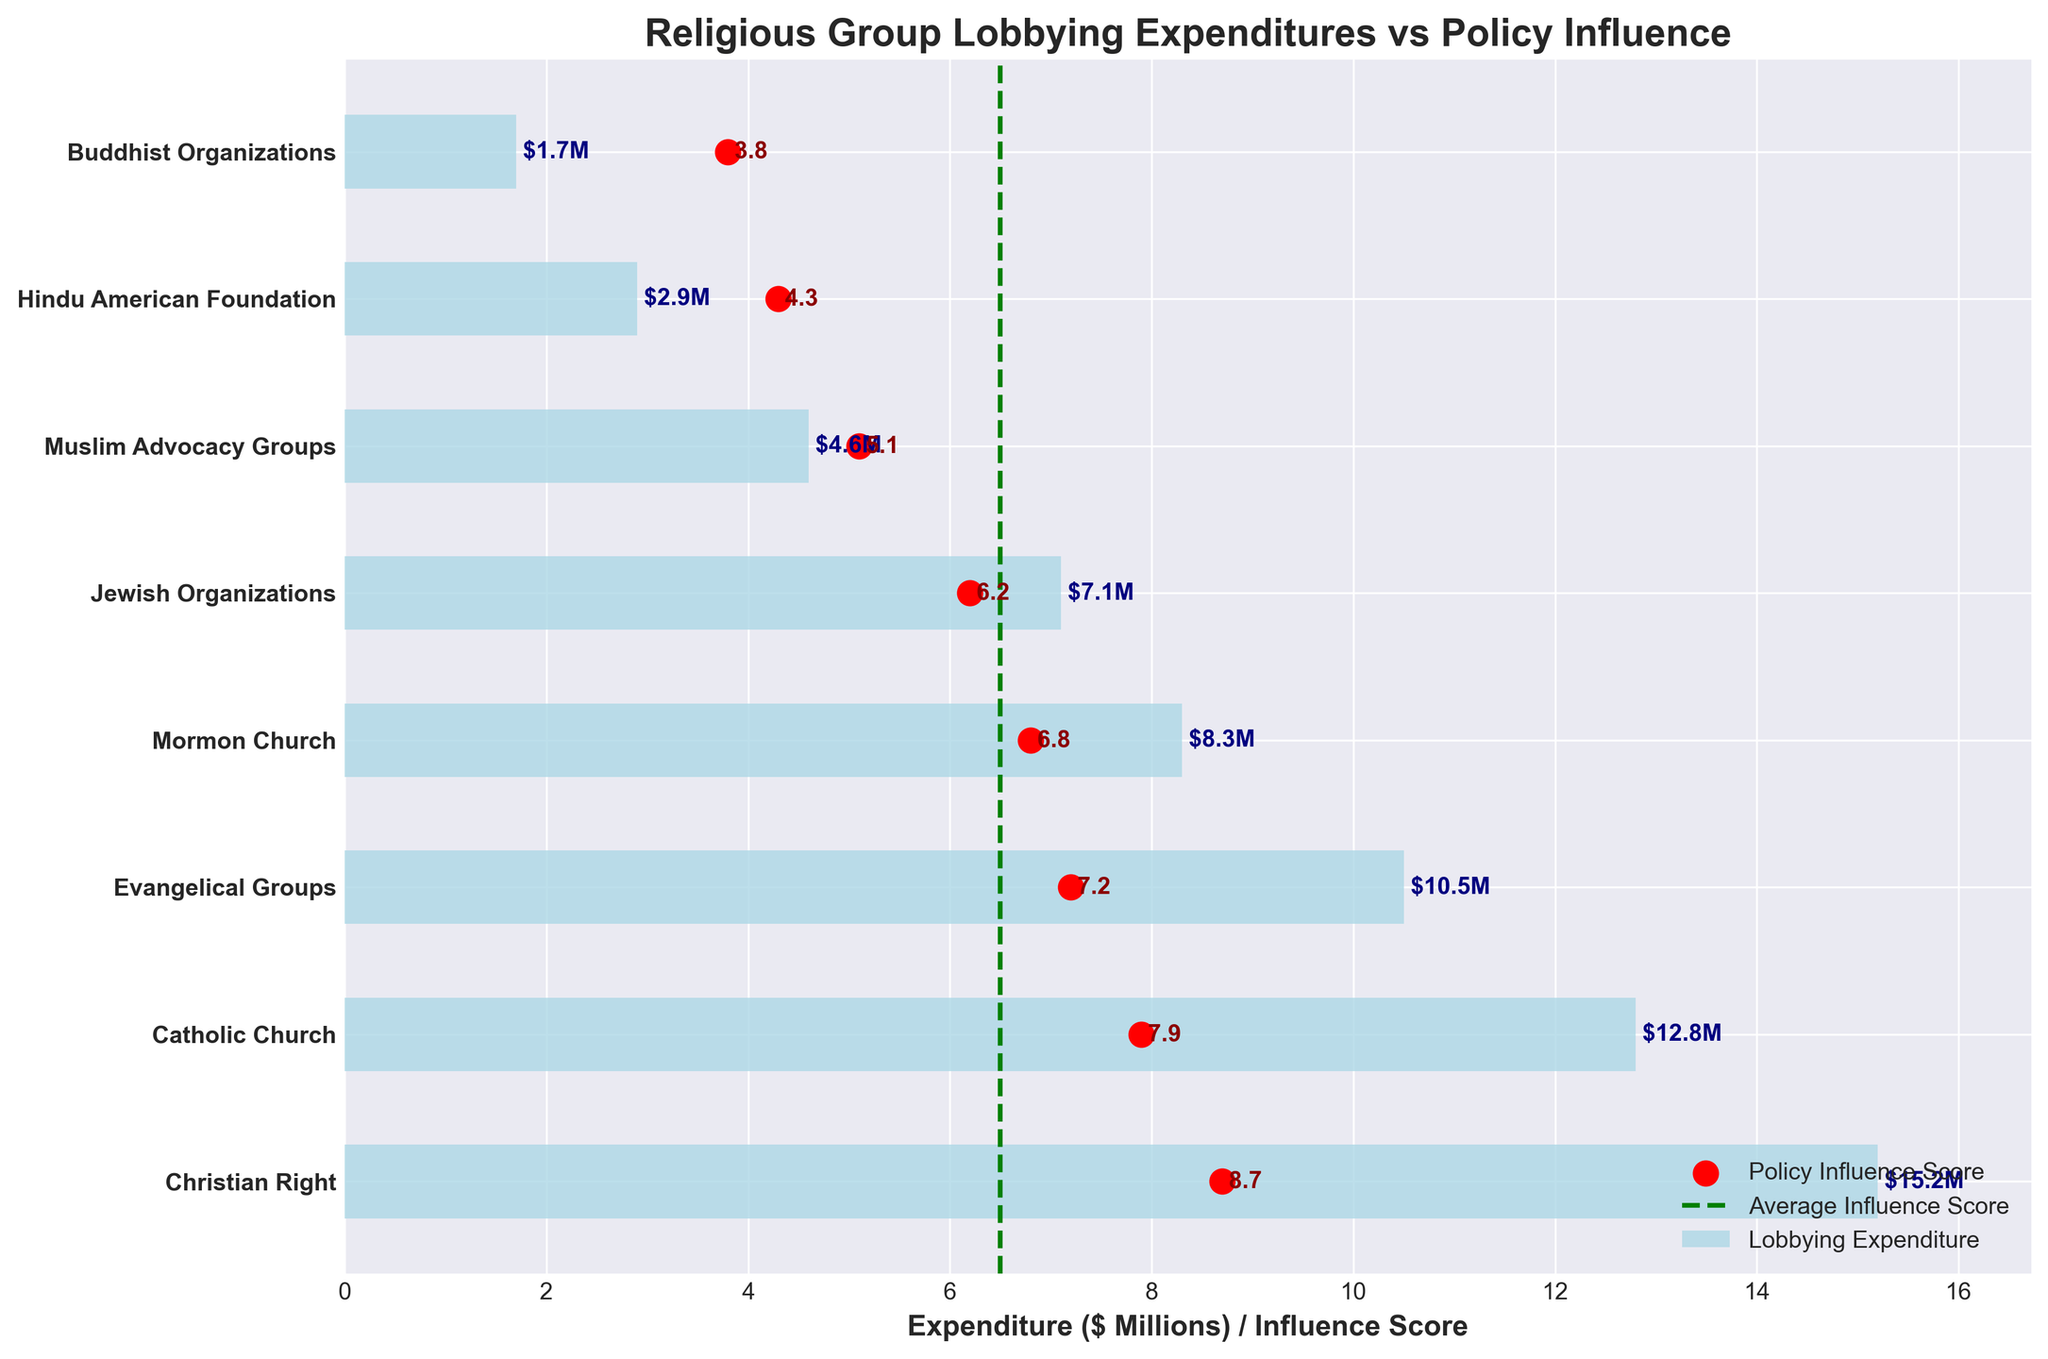What is the title of the figure? The title of the figure is clearly written at the top. It gives an overview of the content and context of the visualized data as "Religious Group Lobbying Expenditures vs Policy Influence".
Answer: Religious Group Lobbying Expenditures vs Policy Influence Which religious group has the highest lobbying expenditure? From the horizontal bars, we can see that the Christian Right has the longest bar, indicating the highest lobbying expenditure.
Answer: Christian Right How does the policy influence score of the Mormon Church compare to the average influence score? The policy influence score for the Mormon Church is 6.8, and the average influence score (marked by a dashed green line) is 6.5. The Mormon Church's score is slightly above the average.
Answer: Slightly above Which religious group has the lowest policy influence score? The dots represent policy influence scores, and the dot for Buddhist Organizations is positioned the lowest on the horizontal axis, indicating the lowest score.
Answer: Buddhist Organizations What is the lobbying expenditure of Jewish Organizations? The length of the horizontal bar for Jewish Organizations indicates their lobbying expenditure, and the value is also labeled beside the bar.
Answer: $7.1 million What is the combined lobbying expenditure of the Evangelical Groups and the Catholic Church? The bar lengths or labeled values show that the Evangelical Groups have an expenditure of $10.5 million and the Catholic Church has $12.8 million. Adding these values gives the total expenditure.
Answer: $23.3 million Is there any group with a policy influence score below the average influence score and a lobbying expenditure above $5 million? By checking each pair, we find that Jewish Organizations have an influence score of 6.2 (below average) and a lobbying expenditure of $7.1 million (above $5 million).
Answer: Yes Which religious group has a lobbying expenditure of 2.9 million dollars? The horizontal bar for the Hindu American Foundation shows an expenditure of $2.9 million, as stated on the bar.
Answer: Hindu American Foundation Does any group have both a policy influence score exactly equal to the average influence score and an expenditure of less than $5 million? Cross-referencing both the influence scores and expenditure bars, we see that no groups meet both criteria simultaneously.
Answer: No What's the difference in influence score between the group with the highest and the lowest lobbying expenditure? The Christian Right has the highest lobbying expenditure ($15.2 million) with an influence score of 8.7, and the Buddhist Organizations have the lowest expenditure ($1.7 million) with an influence score of 3.8. The difference is 8.7 - 3.8.
Answer: 4.9 